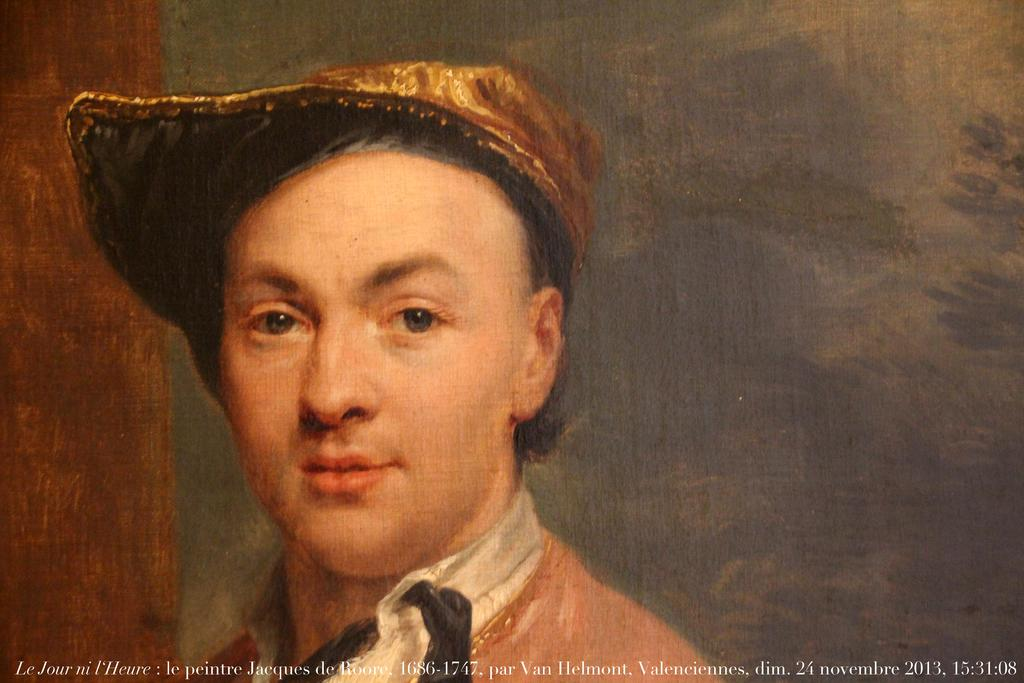What is the main subject of the image? There is a painting in the image. What is depicted in the painting? The painting depicts a person. Can you describe the person's attire in the painting? The person in the painting is wearing a cap. How many twigs are held by the person in the painting? There are no twigs visible in the painting; the person is wearing a cap. 